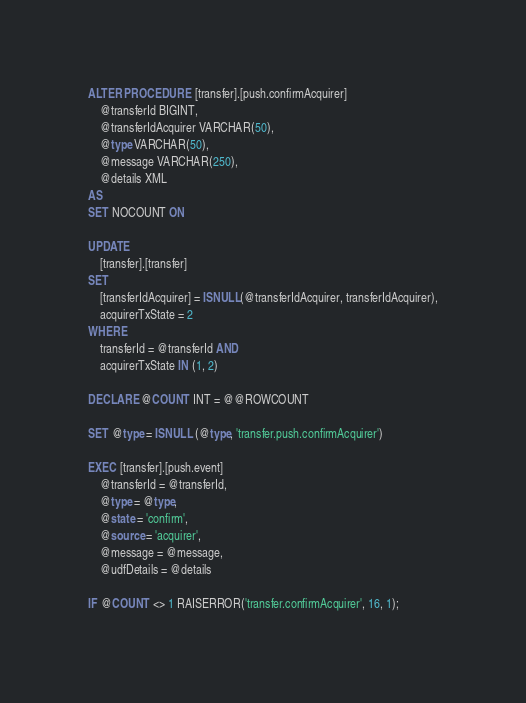Convert code to text. <code><loc_0><loc_0><loc_500><loc_500><_SQL_>ALTER PROCEDURE [transfer].[push.confirmAcquirer]
    @transferId BIGINT,
    @transferIdAcquirer VARCHAR(50),
    @type VARCHAR(50),
    @message VARCHAR(250),
    @details XML
AS
SET NOCOUNT ON

UPDATE
    [transfer].[transfer]
SET
    [transferIdAcquirer] = ISNULL(@transferIdAcquirer, transferIdAcquirer),
    acquirerTxState = 2
WHERE
    transferId = @transferId AND
    acquirerTxState IN (1, 2)

DECLARE @COUNT INT = @@ROWCOUNT

SET @type = ISNULL (@type, 'transfer.push.confirmAcquirer')

EXEC [transfer].[push.event]
    @transferId = @transferId,
    @type = @type,
    @state = 'confirm',
    @source = 'acquirer',
    @message = @message,
    @udfDetails = @details

IF @COUNT <> 1 RAISERROR('transfer.confirmAcquirer', 16, 1);
</code> 